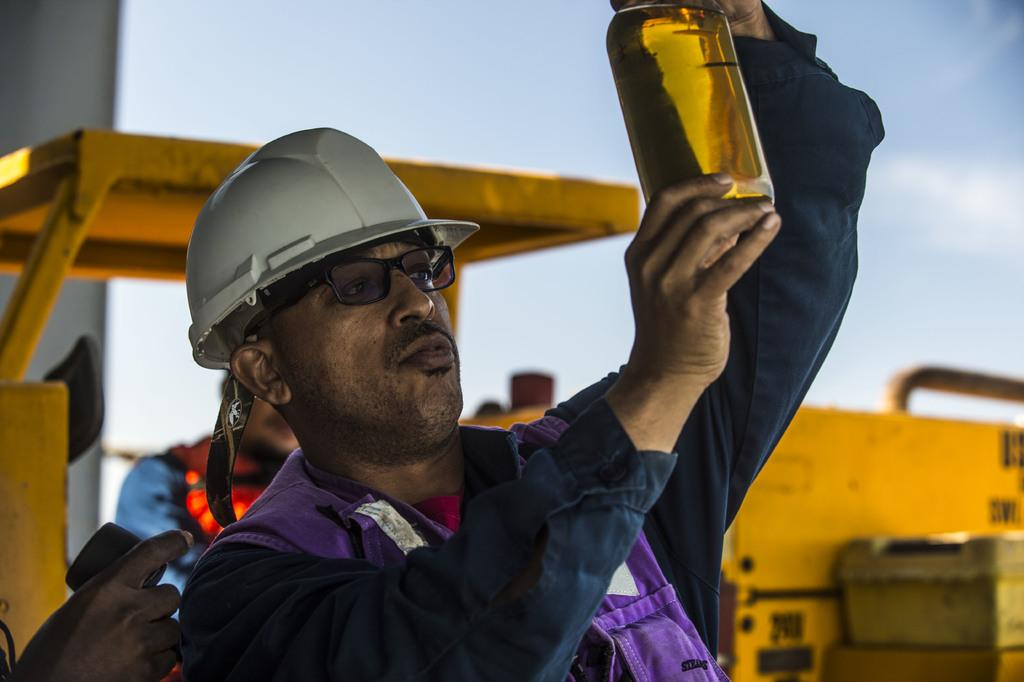How many people are in the image? There are three persons in the image. What are the persons holding in their hands? The persons are holding objects in their hands. What can be seen on the road in the image? There is a vehicle on the road in the image. What type of structure is visible in the image? There is a building in the image. What is visible in the background of the image? The sky is visible in the image. Can you determine the time of day from the image? The image appears to be taken during the day. What type of cream is being used by the person in the image? There is no cream visible in the image, and the persons are not using any cream. 